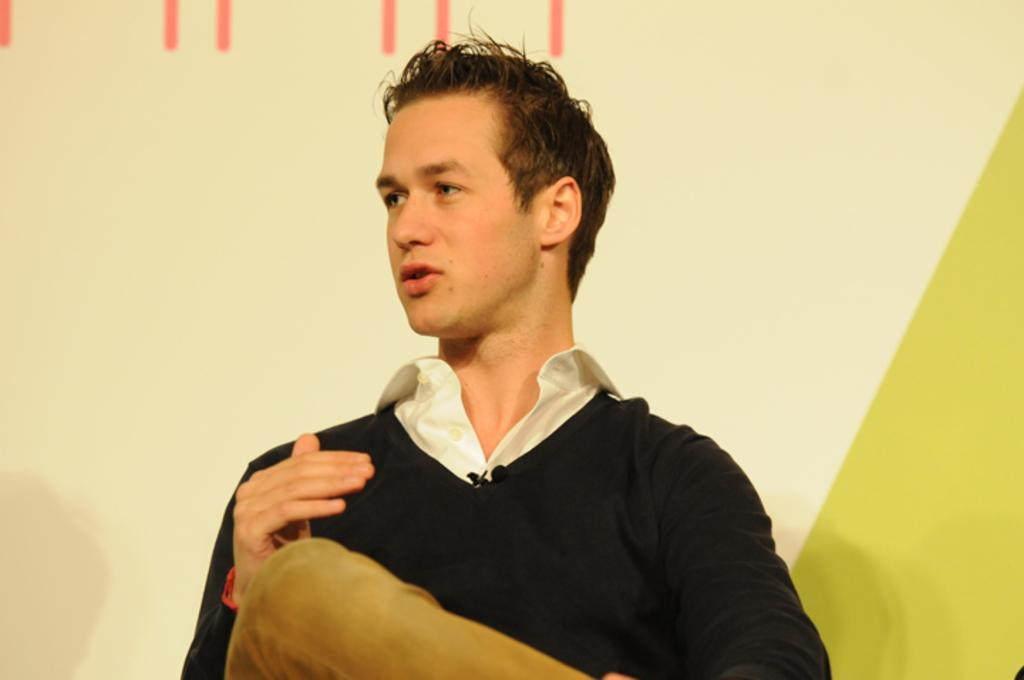What is the main subject of the image? There is a person in the image. What type of ear is visible on the person in the image? There is no ear visible in the image; only the person is present. 